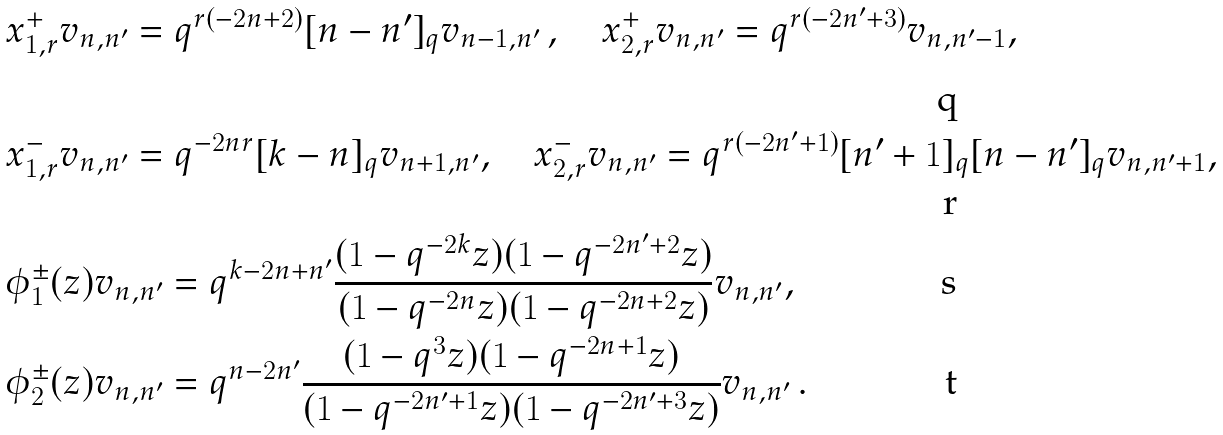<formula> <loc_0><loc_0><loc_500><loc_500>& x _ { 1 , r } ^ { + } v _ { n , n ^ { \prime } } = q ^ { r ( - 2 n + 2 ) } [ n - n ^ { \prime } ] _ { q } v _ { n - 1 , n ^ { \prime } } \, , \quad x _ { 2 , r } ^ { + } v _ { n , n ^ { \prime } } = q ^ { r ( - 2 n ^ { \prime } + 3 ) } v _ { n , n ^ { \prime } - 1 } , \\ & x _ { 1 , r } ^ { - } v _ { n , n ^ { \prime } } = q ^ { - 2 n r } [ k - n ] _ { q } v _ { n + 1 , n ^ { \prime } } , \quad x _ { 2 , r } ^ { - } v _ { n , n ^ { \prime } } = q ^ { r ( - 2 n ^ { \prime } + 1 ) } [ n ^ { \prime } + 1 ] _ { q } [ n - n ^ { \prime } ] _ { q } v _ { n , n ^ { \prime } + 1 } , \\ & \phi _ { 1 } ^ { \pm } ( z ) v _ { n , n ^ { \prime } } = q ^ { k - 2 n + n ^ { \prime } } \frac { ( 1 - q ^ { - 2 k } z ) ( 1 - q ^ { - 2 n ^ { \prime } + 2 } z ) } { ( 1 - q ^ { - 2 n } z ) ( 1 - q ^ { - 2 n + 2 } z ) } v _ { n , n ^ { \prime } } , \\ & \phi _ { 2 } ^ { \pm } ( z ) v _ { n , n ^ { \prime } } = q ^ { n - 2 n ^ { \prime } } \frac { ( 1 - q ^ { 3 } z ) ( 1 - q ^ { - 2 n + 1 } z ) } { ( 1 - q ^ { - 2 n ^ { \prime } + 1 } z ) ( 1 - q ^ { - 2 n ^ { \prime } + 3 } z ) } v _ { n , n ^ { \prime } } \, .</formula> 